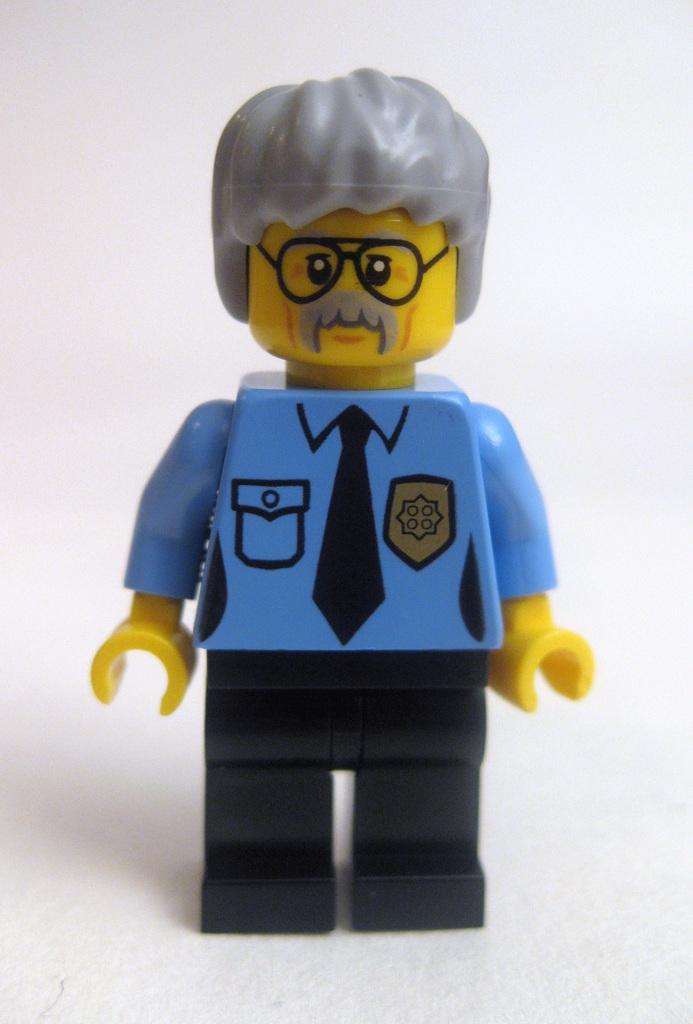What type of object is in the image? There is a toy of a man in the image. What accessories does the toy have? The toy has spectacles, a shirt, trousers, and a tie. What is the color of the background in the image? The background of the image is white. How many turkeys are present in the image? There are no turkeys present in the image; it features a toy of a man with various accessories. 